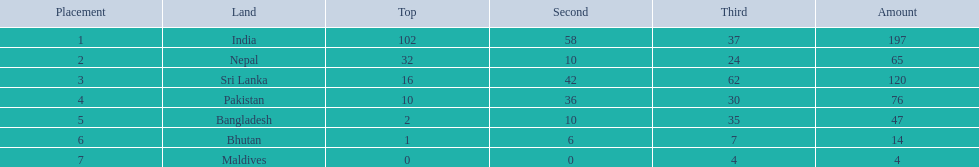What are all the countries listed in the table? India, Nepal, Sri Lanka, Pakistan, Bangladesh, Bhutan, Maldives. Which of these is not india? Nepal, Sri Lanka, Pakistan, Bangladesh, Bhutan, Maldives. Of these, which is first? Nepal. 